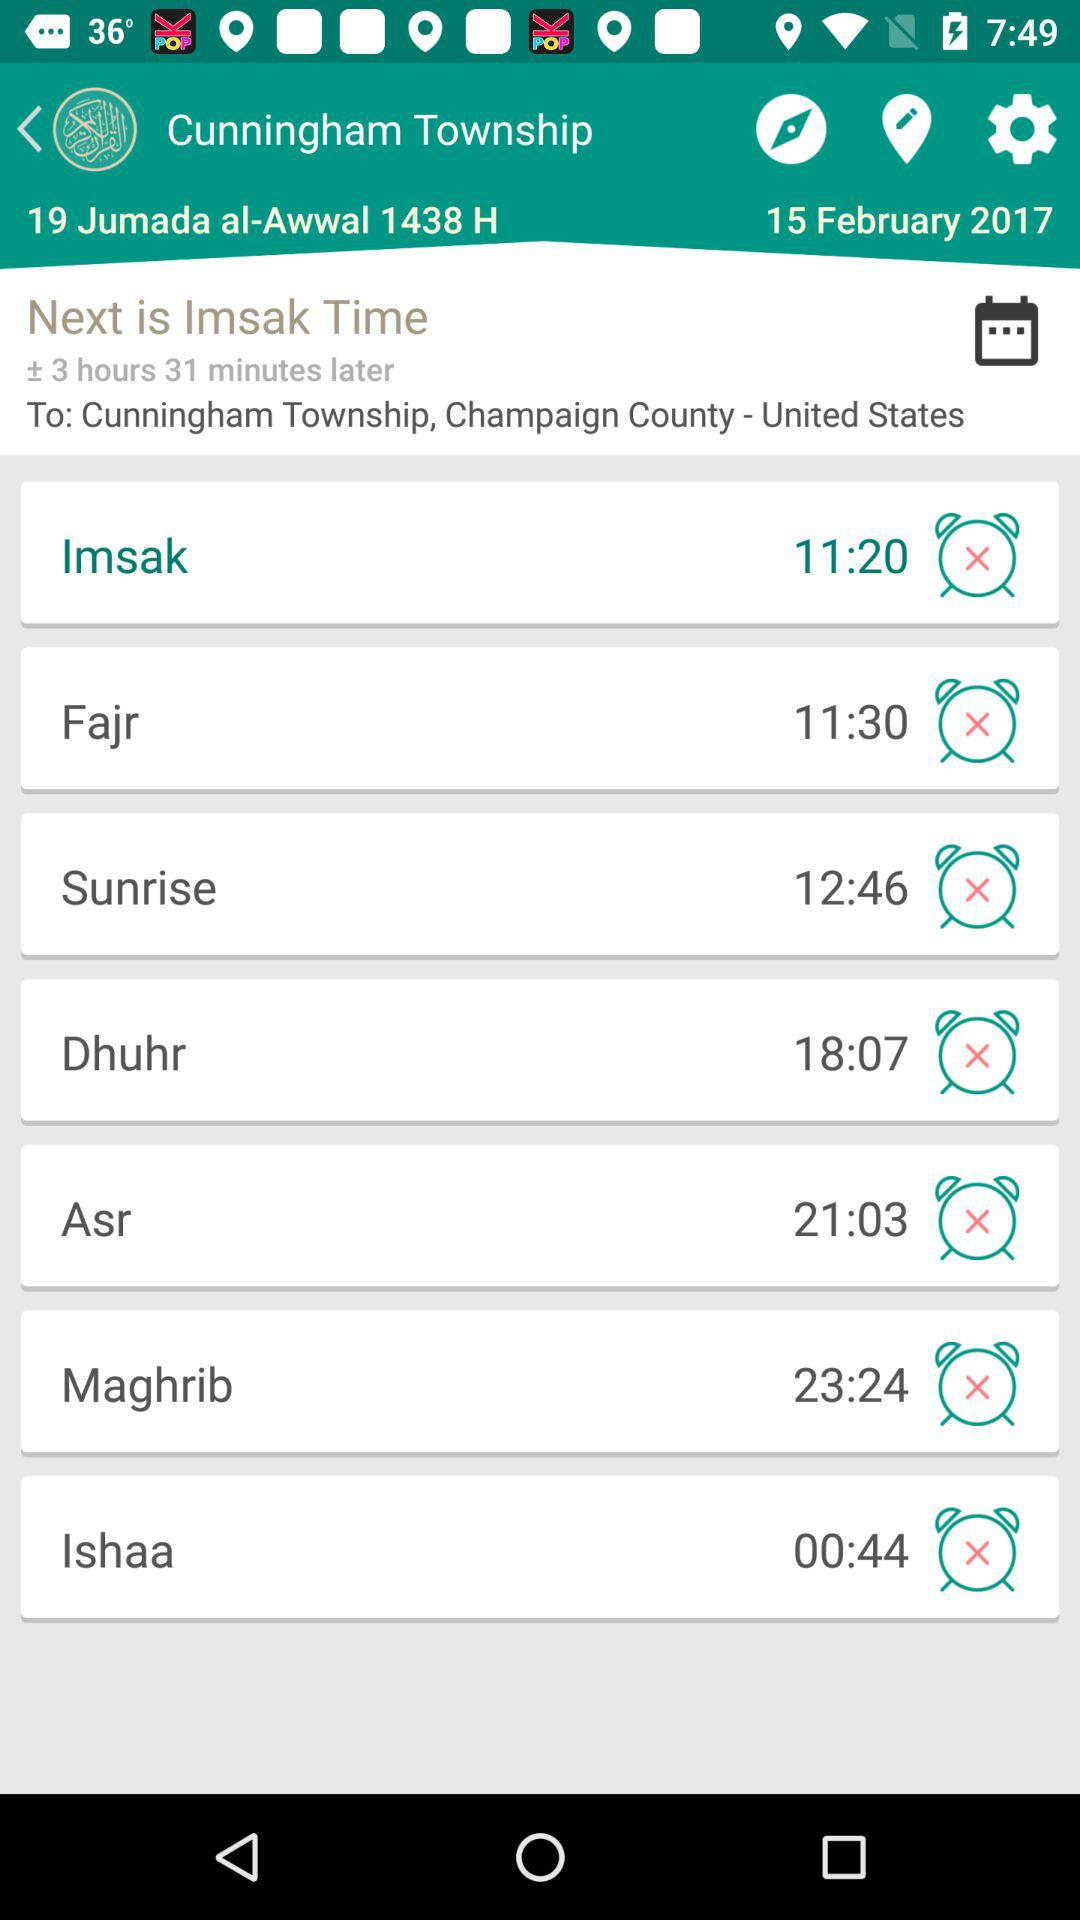What time is shown for "Fajr"? The time is 11:30. 